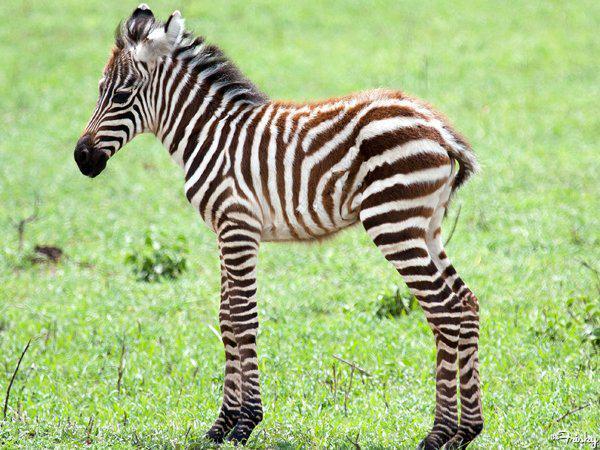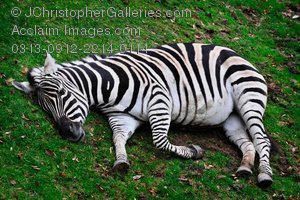The first image is the image on the left, the second image is the image on the right. For the images displayed, is the sentence "Each image shows a zebra resting in the grass, and one image actually shows the zebra in a position with front knees both bent." factually correct? Answer yes or no. No. The first image is the image on the left, the second image is the image on the right. Examine the images to the left and right. Is the description "The zebra in the image on the left is standing in a field." accurate? Answer yes or no. Yes. 